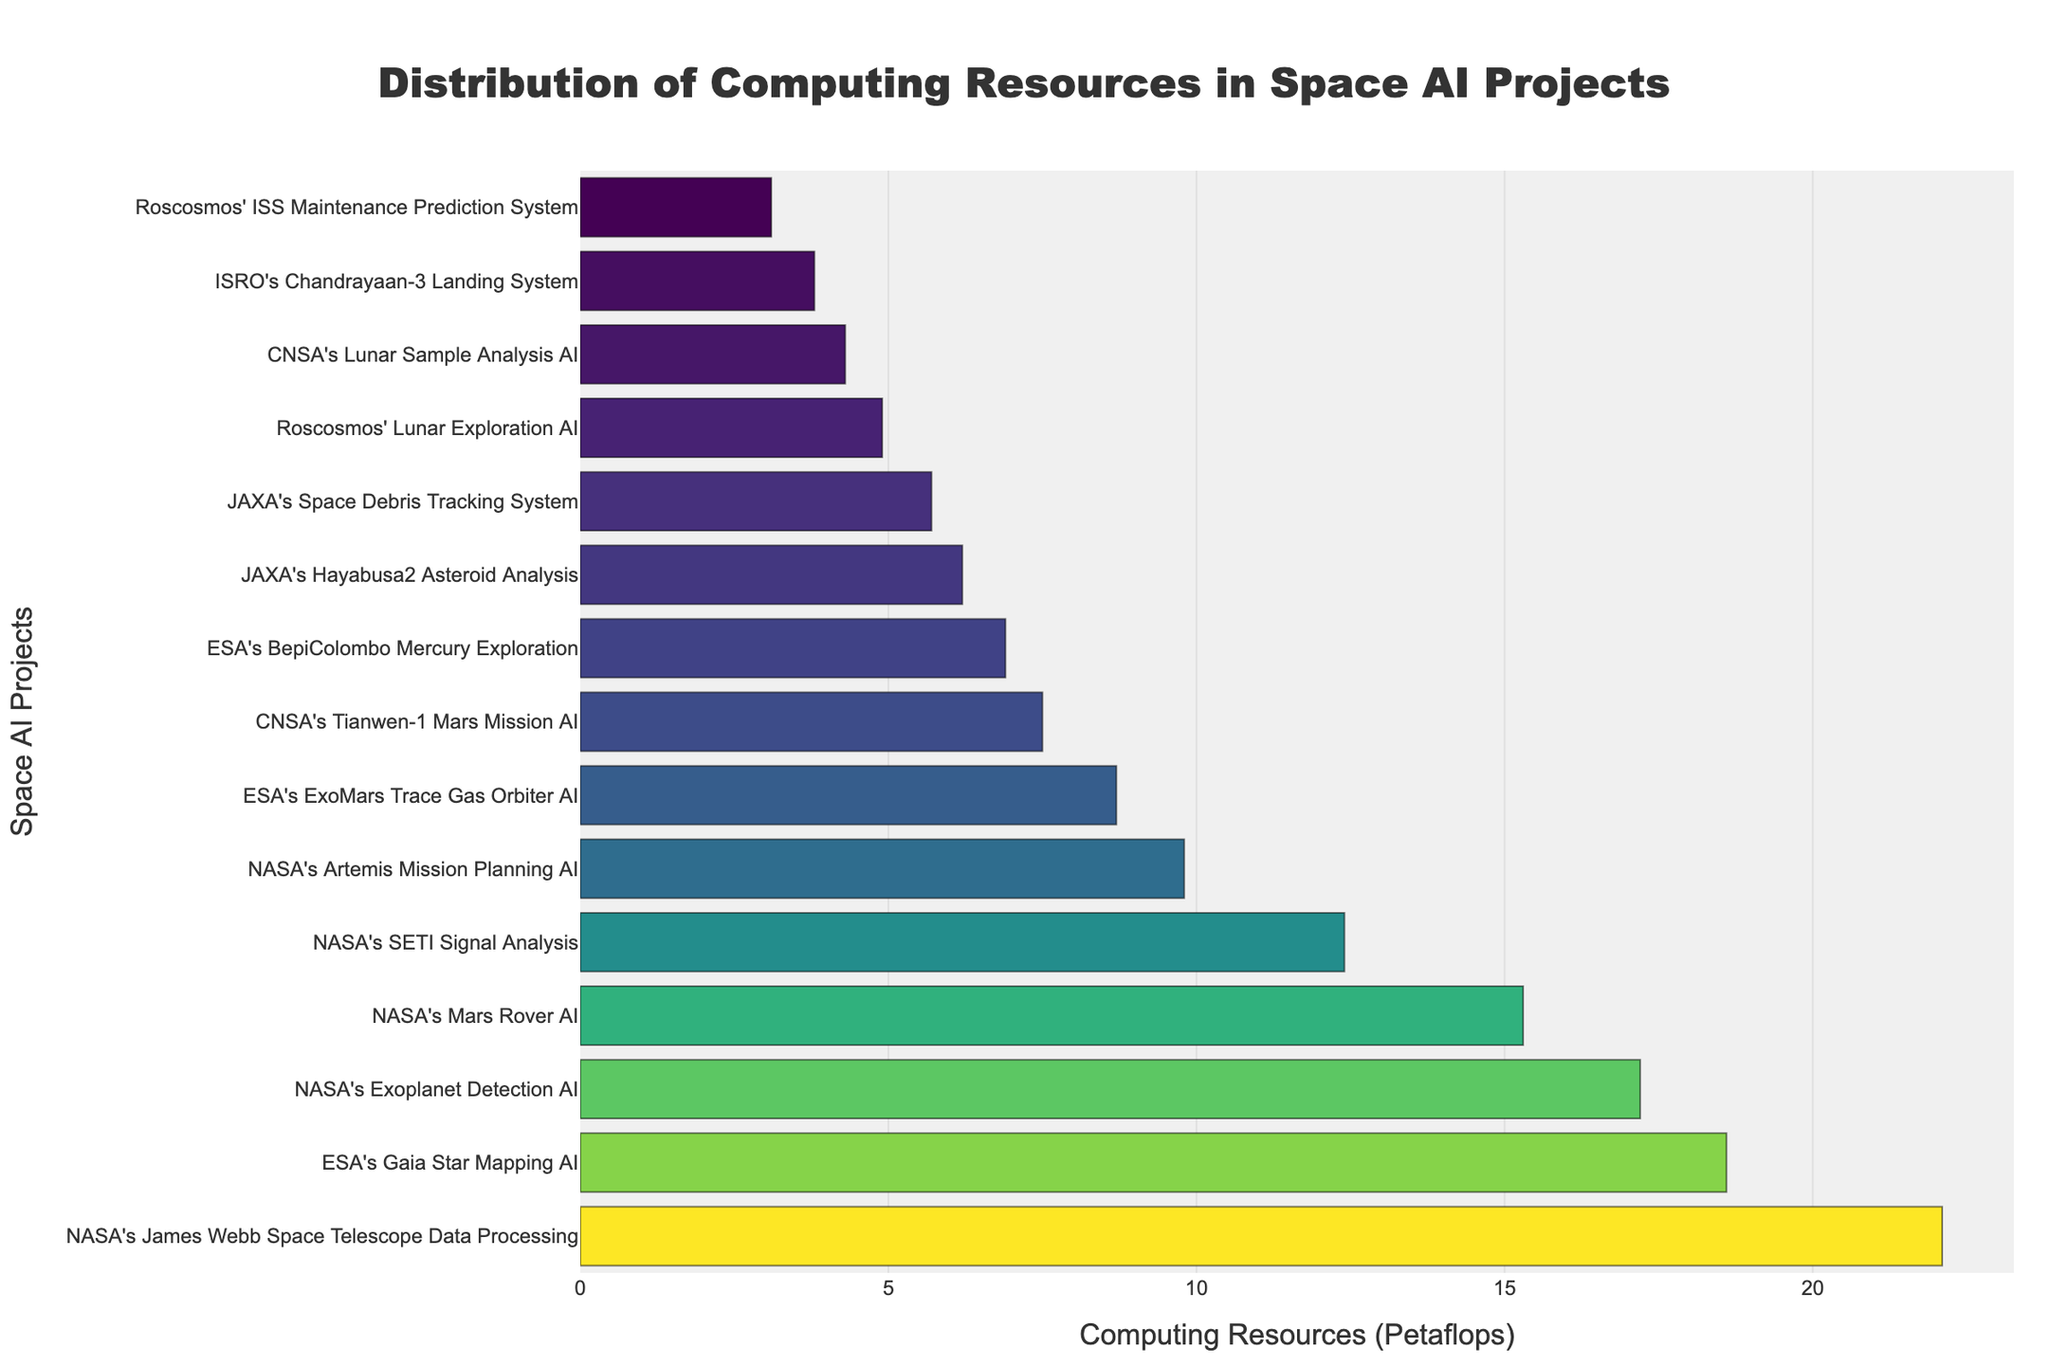Which project has the highest allocation of computing resources? Examine the topmost bar in the chart, which represents the project with the highest computing resources allocation. The length of the bar is the longest, indicating the highest value.
Answer: NASA's James Webb Space Telescope Data Processing What is the combined computing resources of the three NASA projects with the highest allocation? Identify the top three NASA projects by their bar lengths: James Webb Space Telescope Data Processing (22.1 Petaflops), Exoplanet Detection AI (17.2 Petaflops), and SETI Signal Analysis (12.4 Petaflops). Sum these values: 22.1 + 17.2 + 12.4 = 51.7 Petaflops.
Answer: 51.7 Petaflops Which project has a computing resource allocation closest to 10 Petaflops? Look for the bar that has a length closest to the 10 Petaflops mark on the x-axis. The closest bar appears to be NASA's Artemis Mission Planning AI with 9.8 Petaflops.
Answer: NASA's Artemis Mission Planning AI How many projects have more than 15 Petaflops of computing resources allocated? Count the number of bars extending beyond the 15 Petaflops mark on the x-axis. These are three projects: NASA's James Webb Space Telescope Data Processing, ESA's Gaia Star Mapping AI, and NASA's Exoplanet Detection AI.
Answer: Three Is the computing resources allocation for CNSA's Tianwen-1 Mars Mission AI higher than JAXA's Hayabusa2 Asteroid Analysis? Compare the lengths of the bars for CNSA's Tianwen-1 Mars Mission AI (7.5 Petaflops) and JAXA's Hayabusa2 Asteroid Analysis (6.2 Petaflops). Tianwen-1's bar is longer.
Answer: Yes What are the total computing resources allocated to ESA's projects? Identify and sum the computing resources of ESA's projects: ExoMars Trace Gas Orbiter AI (8.7 Petaflops), Gaia Star Mapping AI (18.6 Petaflops), and BepiColombo Mercury Exploration (6.9 Petaflops). Calculate the total: 8.7 + 18.6 + 6.9 = 34.2 Petaflops.
Answer: 34.2 Petaflops What is the difference in computing resources between the highest and lowest allocated projects? Identify the highest allocation (NASA's James Webb Space Telescope Data Processing at 22.1 Petaflops) and the lowest allocation (Roscosmos' ISS Maintenance Prediction System at 3.1 Petaflops). Subtract the latter from the former: 22.1 - 3.1 = 19 Petaflops.
Answer: 19 Petaflops Which project has the second-highest computing resources allocation? Locate the second longest bar in the chart, which represents the project with the second-highest computing resources allocation. This is ESA's Gaia Star Mapping AI with 18.6 Petaflops.
Answer: ESA's Gaia Star Mapping AI What percentage of the total computing resources does NASA's James Webb Space Telescope Data Processing project utilize? First, sum the computing resources of all projects, then calculate the percentage. The total is the sum of all provided values, i.e., 15.3 + 8.7 + 6.2 + 4.9 + 3.8 + 7.5 + 22.1 + 18.6 + 12.4 + 5.7 + 9.8 + 6.9 + 4.3 + 17.2 + 3.1 = 146.5 Petaflops. Then, compute the percentage: (22.1 / 146.5) * 100 ≈ 15.1%.
Answer: 15.1% Which agency has the most projects listed in the chart? Count the number of projects listed under each space agency. NASA has the most projects with a total of five: Mars Rover AI, James Webb Space Telescope Data Processing, SETI Signal Analysis, Artemis Mission Planning AI, and Exoplanet Detection AI.
Answer: NASA 